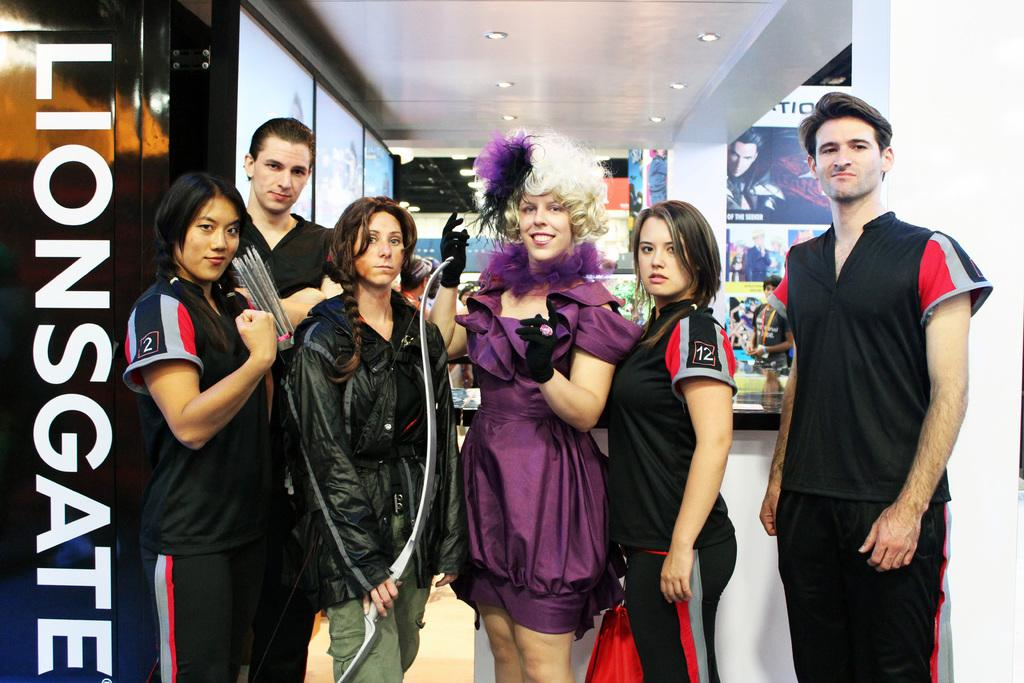<image>
Summarize the visual content of the image. A group of people stand posing for a picture and the word liongate is down the side. 